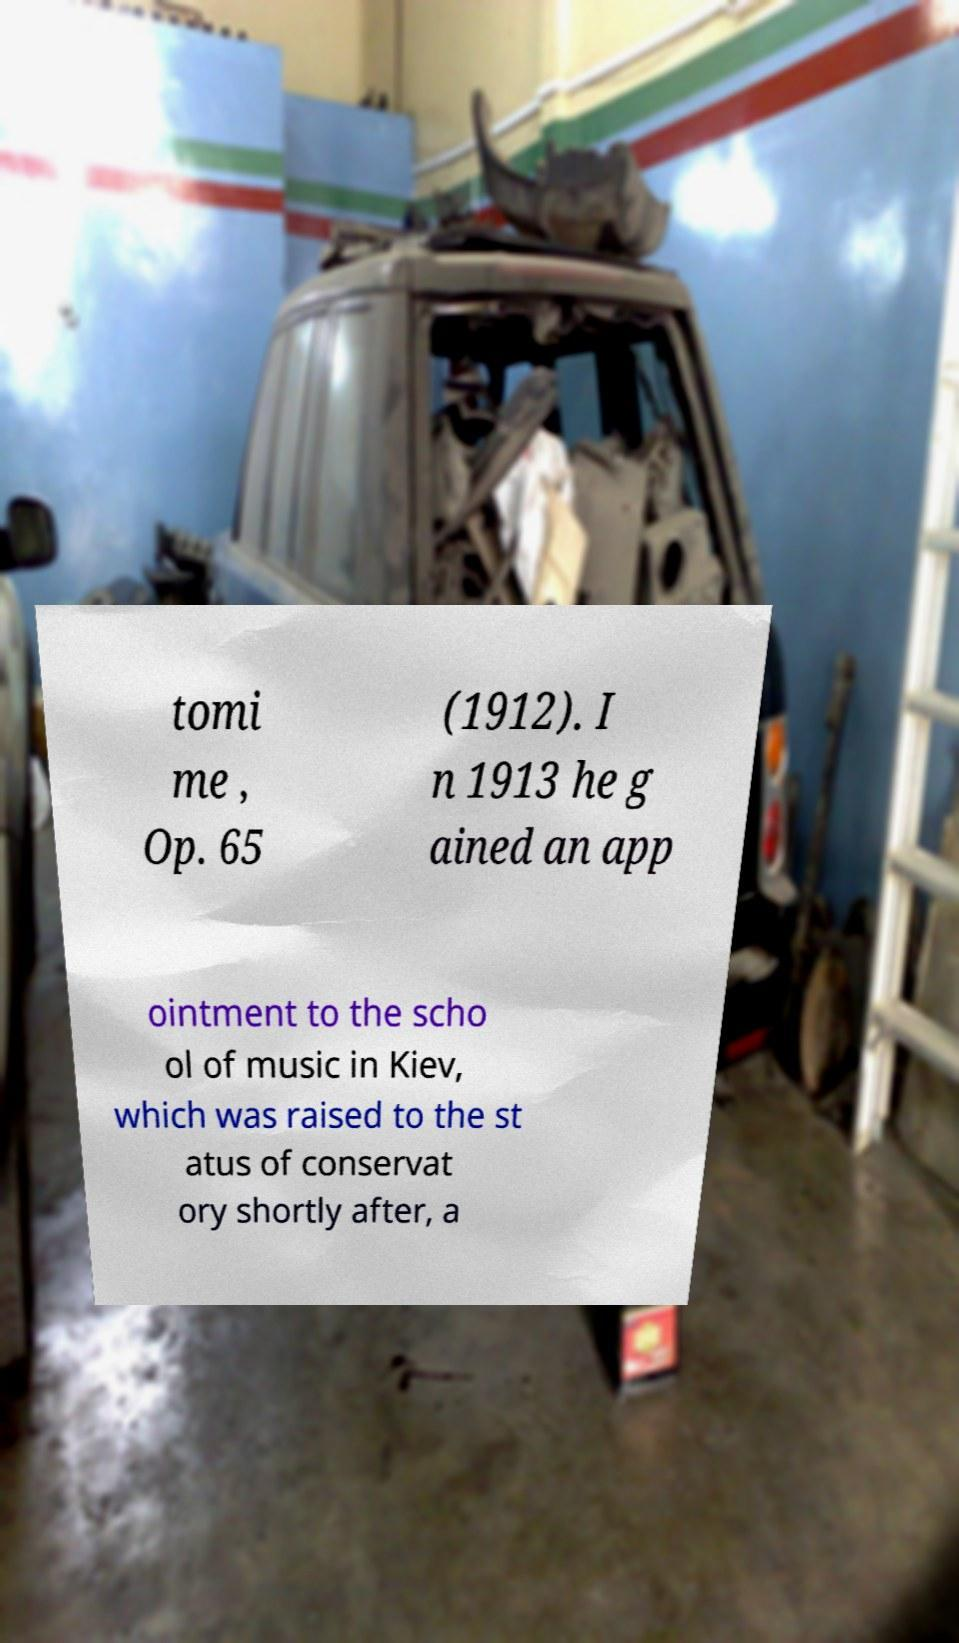Could you extract and type out the text from this image? tomi me , Op. 65 (1912). I n 1913 he g ained an app ointment to the scho ol of music in Kiev, which was raised to the st atus of conservat ory shortly after, a 